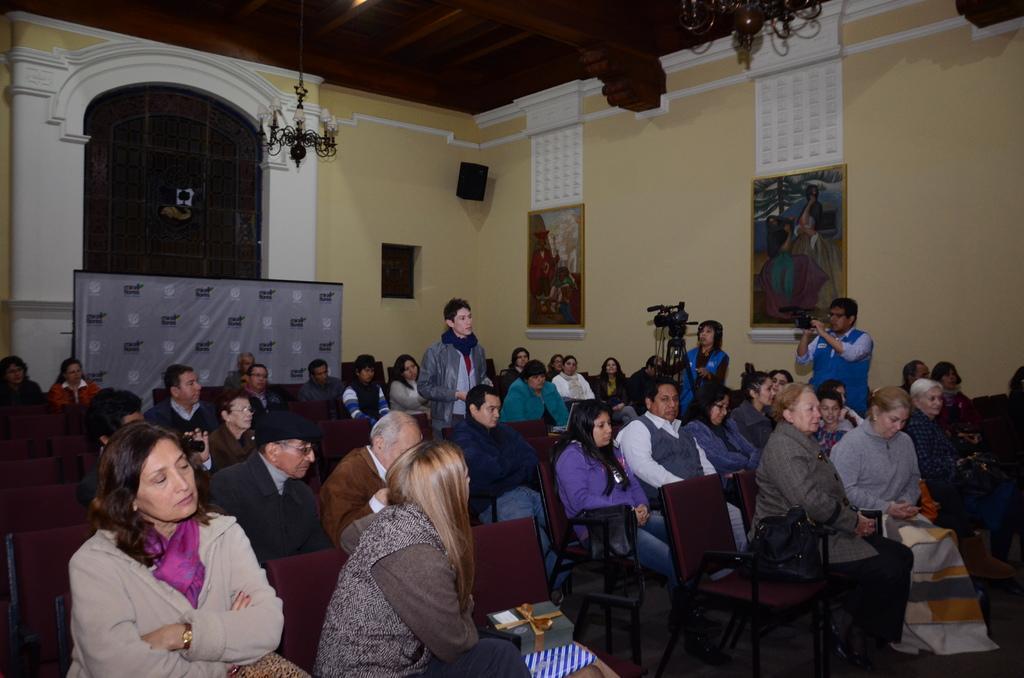Describe this image in one or two sentences. As we can see in the image there is a wall, calendar, photo frame and few people standing and sitting here and there and there are chairs and there is a camera over here. 